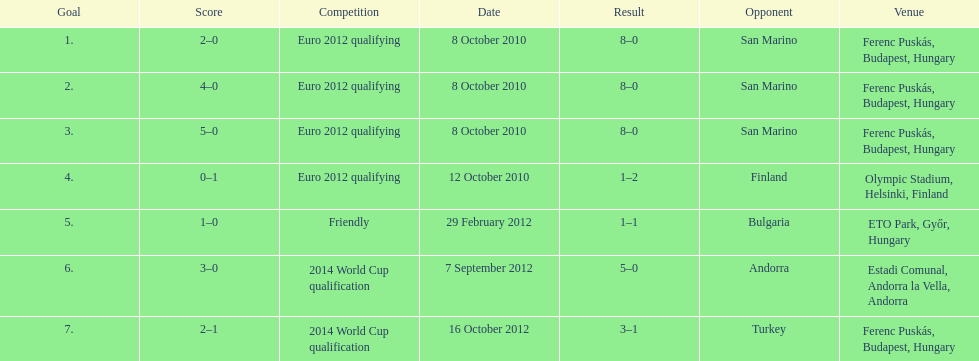How many goals were scored at the euro 2012 qualifying competition? 12. 